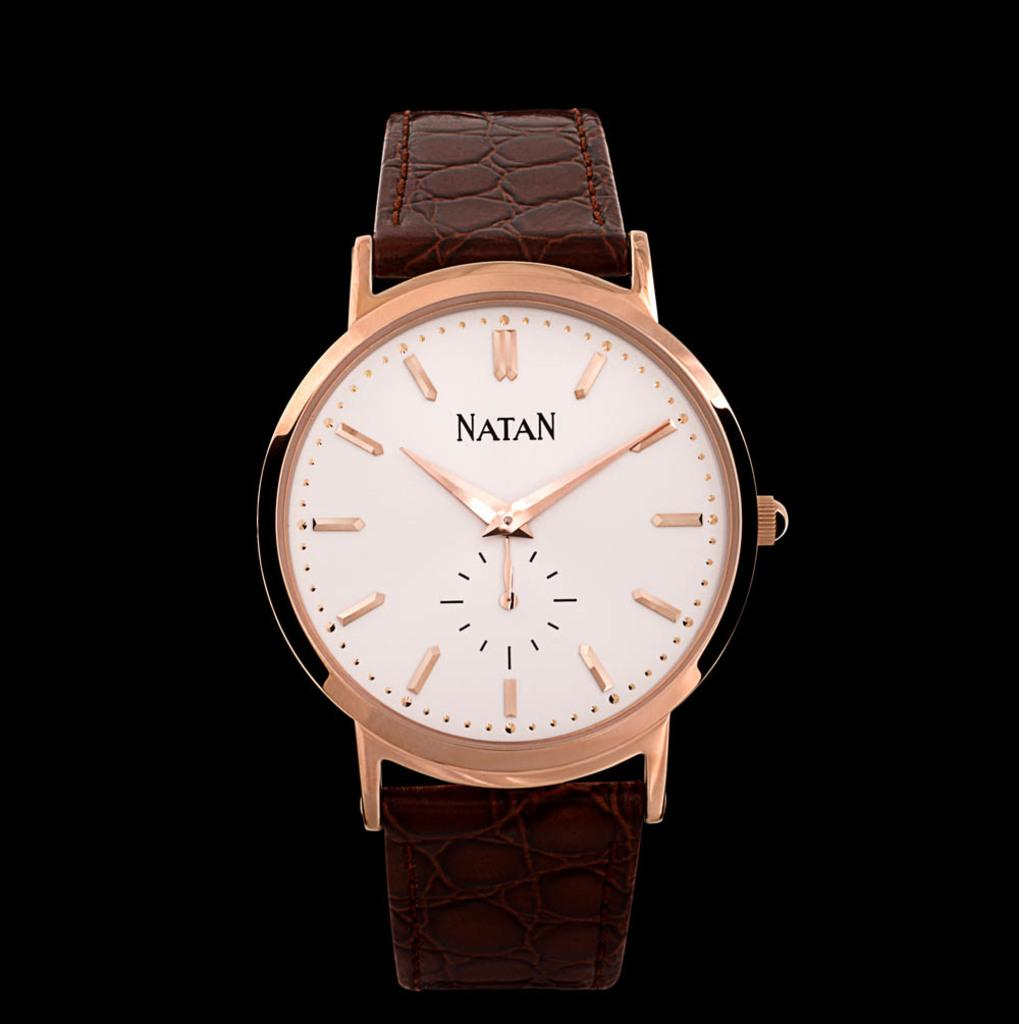What object is the main subject of the image? There is a watch in the image. What material is used for the watch's belt? The watch has a leather belt. What color is the background of the image? The background of the image is black. Can you tell me how many monkeys are sitting on the watch in the image? There are no monkeys present in the image; it features a watch with a leather belt against a black background. What is the relation between the watch and the monkeys in the image? There are no monkeys in the image, so there is no relation between the watch and any monkeys. 